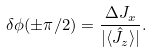Convert formula to latex. <formula><loc_0><loc_0><loc_500><loc_500>\delta \phi ( \pm \pi / 2 ) = \frac { \Delta J _ { x } } { | \langle \hat { J } _ { z } \rangle | } .</formula> 